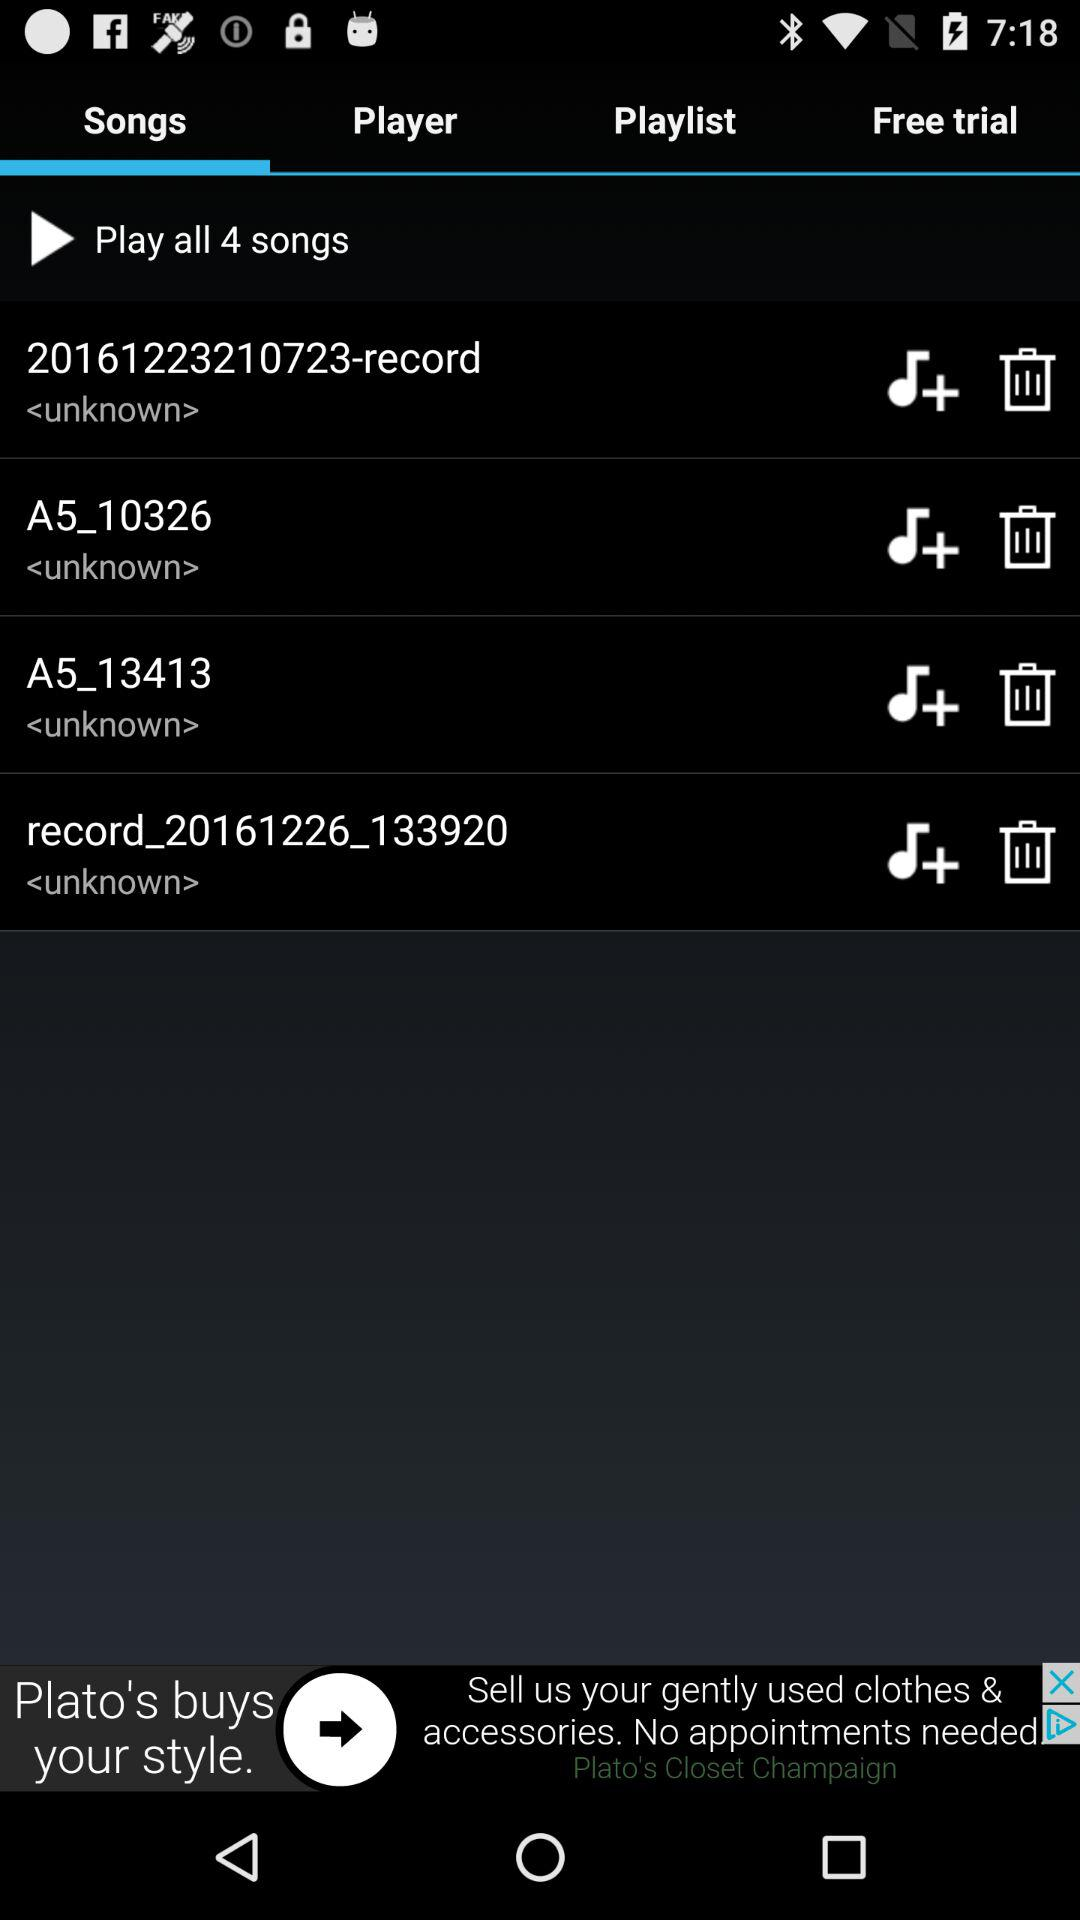Which tab is selected? The selected tab is "Songs". 